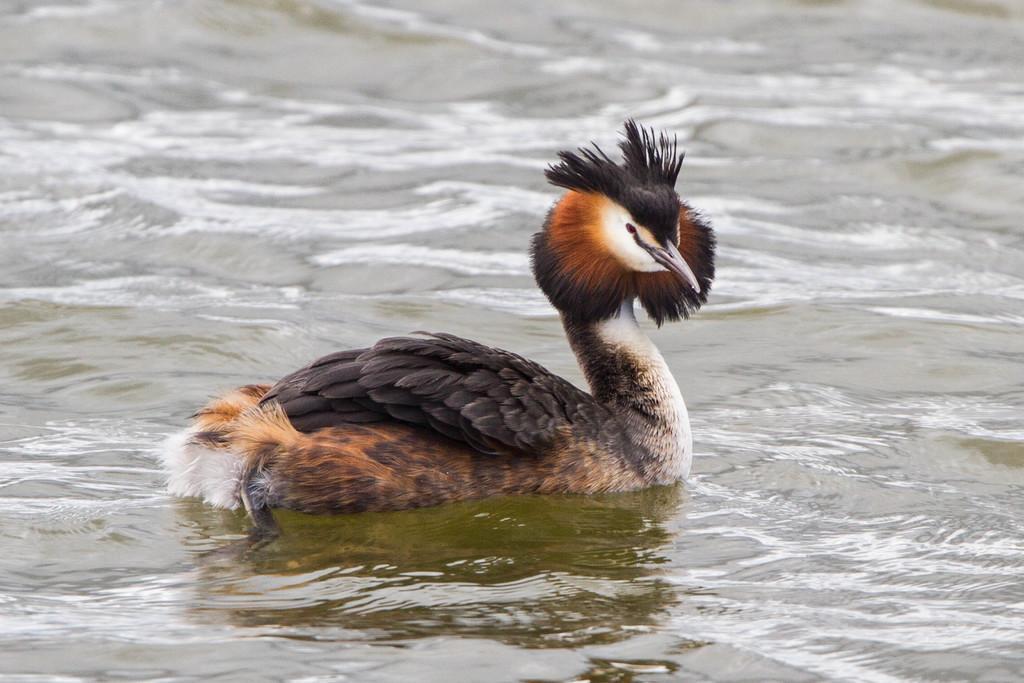Could you give a brief overview of what you see in this image? In the middle of the picture, we see a bird which looks like a duck is swimming in the water and this water might be in the pond. It has a long beak and it is in black and brown color. 